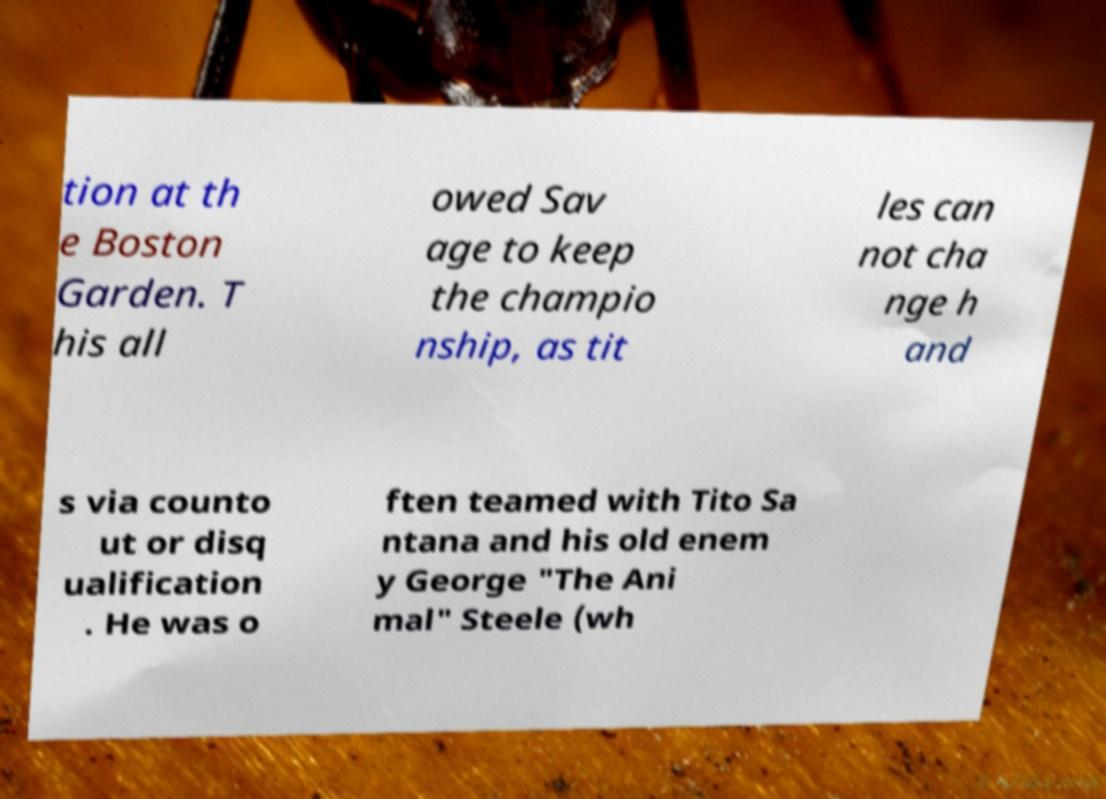For documentation purposes, I need the text within this image transcribed. Could you provide that? tion at th e Boston Garden. T his all owed Sav age to keep the champio nship, as tit les can not cha nge h and s via counto ut or disq ualification . He was o ften teamed with Tito Sa ntana and his old enem y George "The Ani mal" Steele (wh 